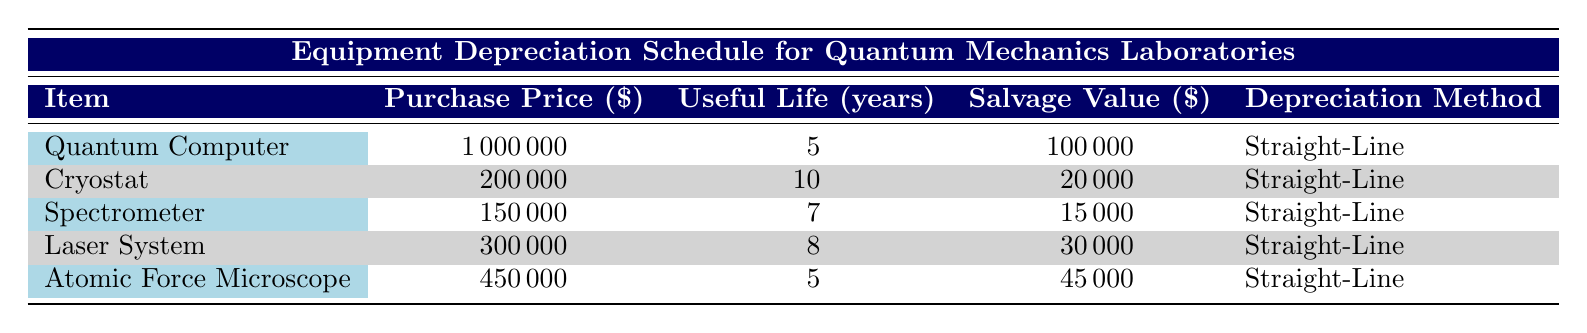What is the purchase price of the Cryostat? The Cryostat is listed in the table with its purchase price specified under the Purchase Price column, which shows 200000.
Answer: 200000 How many years is the useful life of the Spectrometer? The Spectrometer is shown in the table along with its useful life, which is listed as 7 years in the Useful Life column.
Answer: 7 years What is the total purchase price of all equipment listed? To find the total purchase price, add up the purchase prices of each item: 1000000 + 200000 + 150000 + 300000 + 450000 = 2150000.
Answer: 2150000 Does the Laser System have a salvage value greater than 20000? The Laser System's salvage value of 30000 is compared to 20000, and since 30000 is greater than 20000, the answer is true.
Answer: Yes Which equipment has the longest useful life based on the table? The useful life for the Cryostat is the longest at 10 years compared to the others, making it the equipment with the longest useful life.
Answer: Cryostat What is the average salvage value of the equipment? To find the average, sum the salvage values (100000 + 20000 + 15000 + 30000 + 45000 = 215000) and divide by the number of items (5), yielding an average of 215000 / 5 = 43000.
Answer: 43000 Is the purchase price of the Quantum Computer more than 800000? Checking the price of the Quantum Computer, which is 1000000, it is clear that this value is greater than 800000, leading to a true statement.
Answer: Yes What is the depreciation method used for all equipment listed? Each item in the table specifies the depreciation method, which is consistently the Straight-Line method for all items listed.
Answer: Straight-Line 